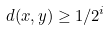Convert formula to latex. <formula><loc_0><loc_0><loc_500><loc_500>d ( x , y ) \geq 1 / 2 ^ { i }</formula> 